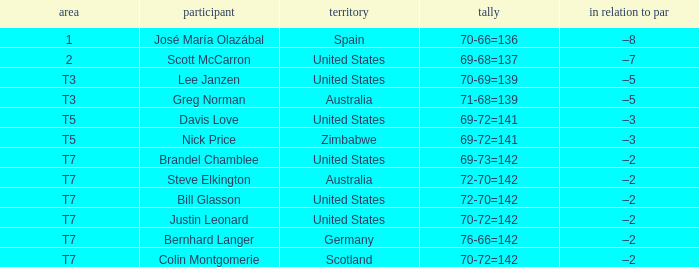WHich Place has a To par of –2, and a Player of bernhard langer? T7. 